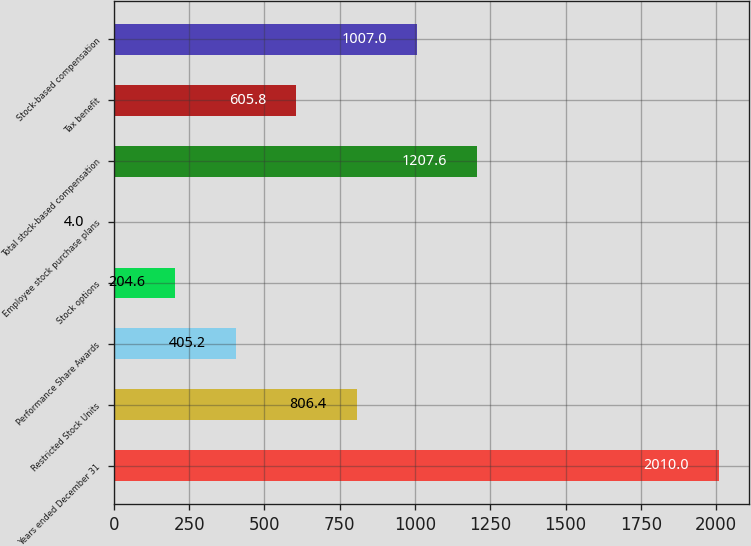Convert chart. <chart><loc_0><loc_0><loc_500><loc_500><bar_chart><fcel>Years ended December 31<fcel>Restricted Stock Units<fcel>Performance Share Awards<fcel>Stock options<fcel>Employee stock purchase plans<fcel>Total stock-based compensation<fcel>Tax benefit<fcel>Stock-based compensation<nl><fcel>2010<fcel>806.4<fcel>405.2<fcel>204.6<fcel>4<fcel>1207.6<fcel>605.8<fcel>1007<nl></chart> 